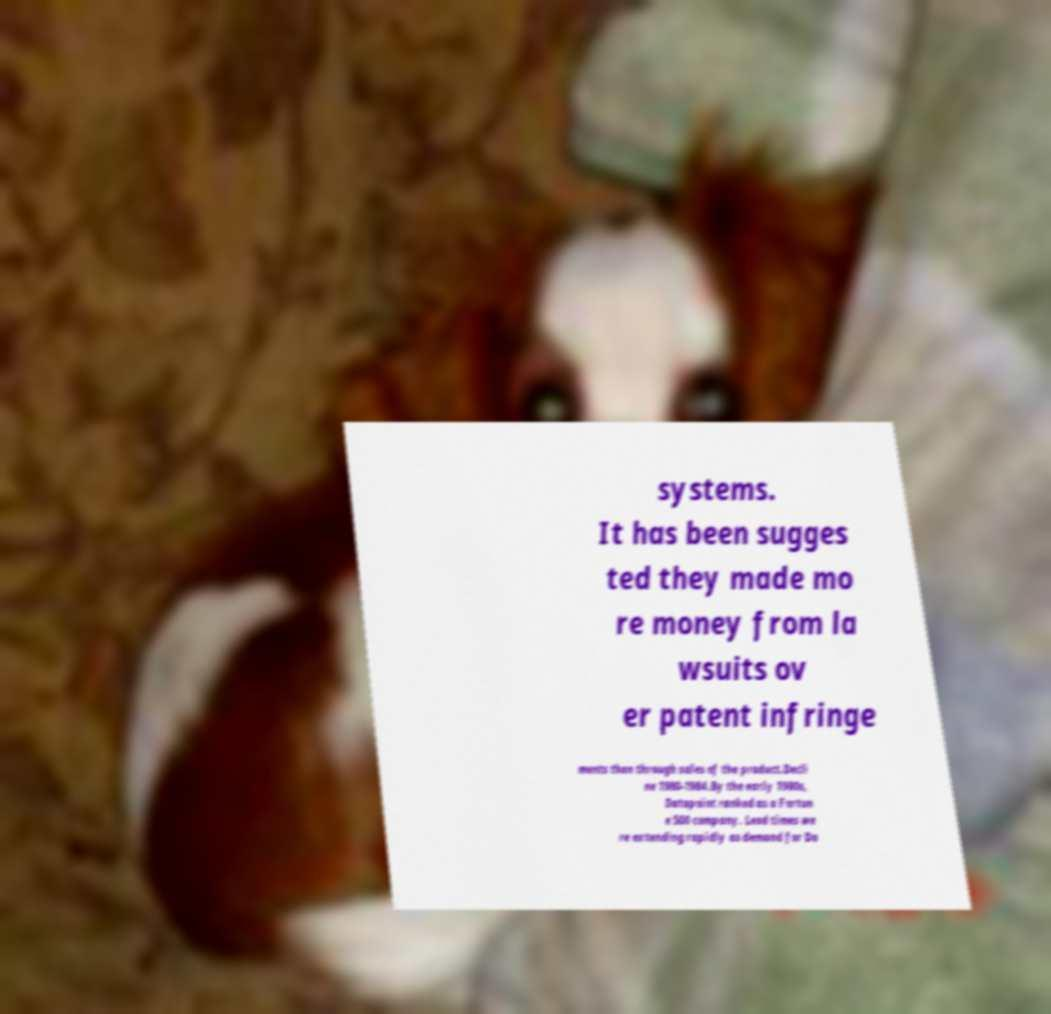Can you accurately transcribe the text from the provided image for me? systems. It has been sugges ted they made mo re money from la wsuits ov er patent infringe ments than through sales of the product.Decli ne 1980-1984.By the early 1980s, Datapoint ranked as a Fortun e 500 company. Lead times we re extending rapidly as demand for Da 